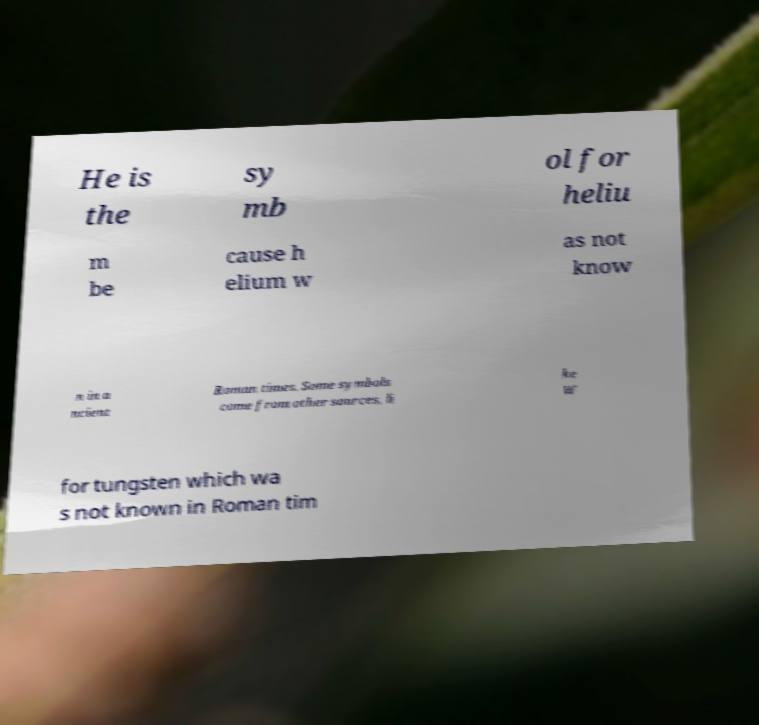Can you accurately transcribe the text from the provided image for me? He is the sy mb ol for heliu m be cause h elium w as not know n in a ncient Roman times. Some symbols come from other sources, li ke W for tungsten which wa s not known in Roman tim 